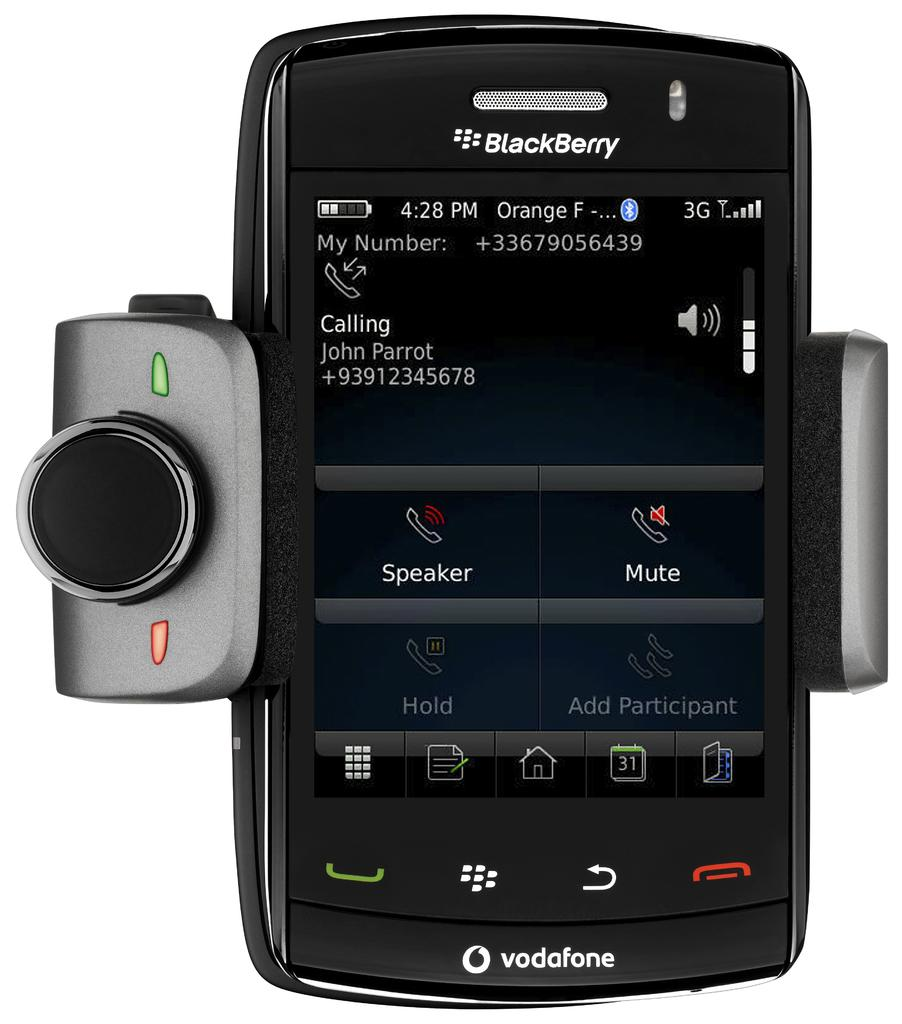<image>
Present a compact description of the photo's key features. a phone with the word Blackberry at the top 